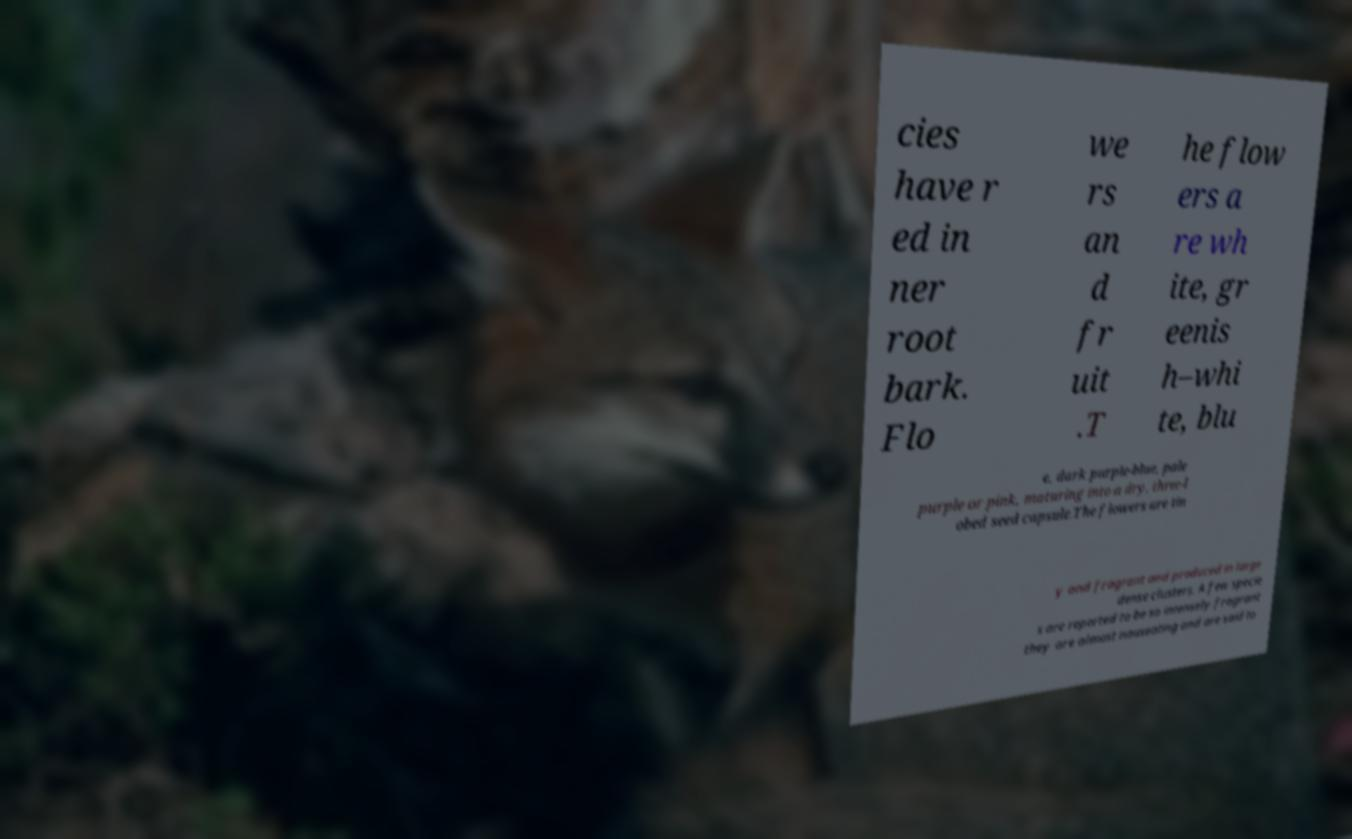Can you accurately transcribe the text from the provided image for me? cies have r ed in ner root bark. Flo we rs an d fr uit .T he flow ers a re wh ite, gr eenis h–whi te, blu e, dark purple-blue, pale purple or pink, maturing into a dry, three-l obed seed capsule.The flowers are tin y and fragrant and produced in large dense clusters. A few specie s are reported to be so intensely fragrant they are almost nauseating and are said to 